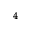Convert formula to latex. <formula><loc_0><loc_0><loc_500><loc_500>^ { 4 }</formula> 